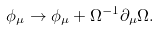<formula> <loc_0><loc_0><loc_500><loc_500>\phi _ { \mu } \rightarrow \phi _ { \mu } + \Omega ^ { - 1 } \partial _ { \mu } \Omega .</formula> 